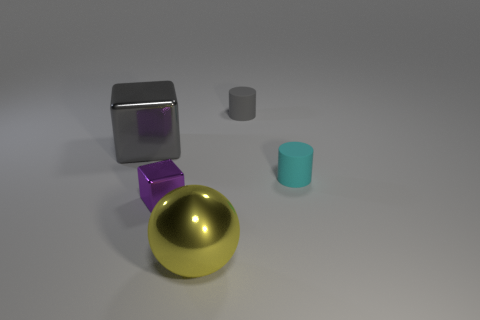Add 4 brown matte blocks. How many objects exist? 9 Subtract all balls. How many objects are left? 4 Subtract all large brown metal spheres. Subtract all gray metal cubes. How many objects are left? 4 Add 3 large shiny blocks. How many large shiny blocks are left? 4 Add 5 large brown metallic things. How many large brown metallic things exist? 5 Subtract 0 purple cylinders. How many objects are left? 5 